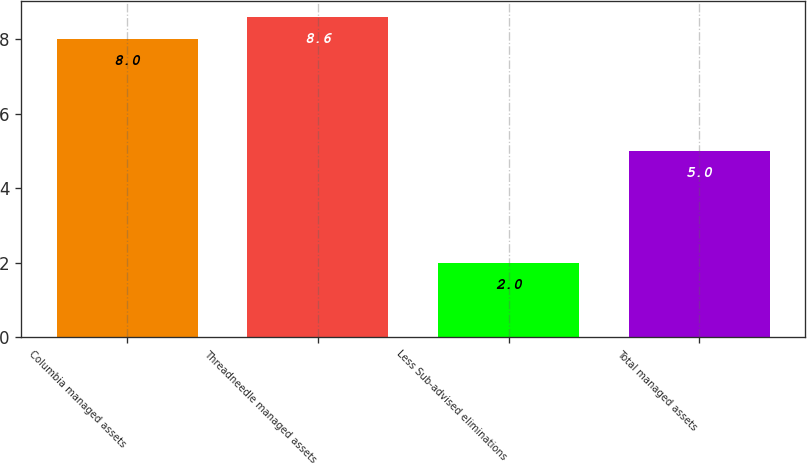<chart> <loc_0><loc_0><loc_500><loc_500><bar_chart><fcel>Columbia managed assets<fcel>Threadneedle managed assets<fcel>Less Sub-advised eliminations<fcel>Total managed assets<nl><fcel>8<fcel>8.6<fcel>2<fcel>5<nl></chart> 